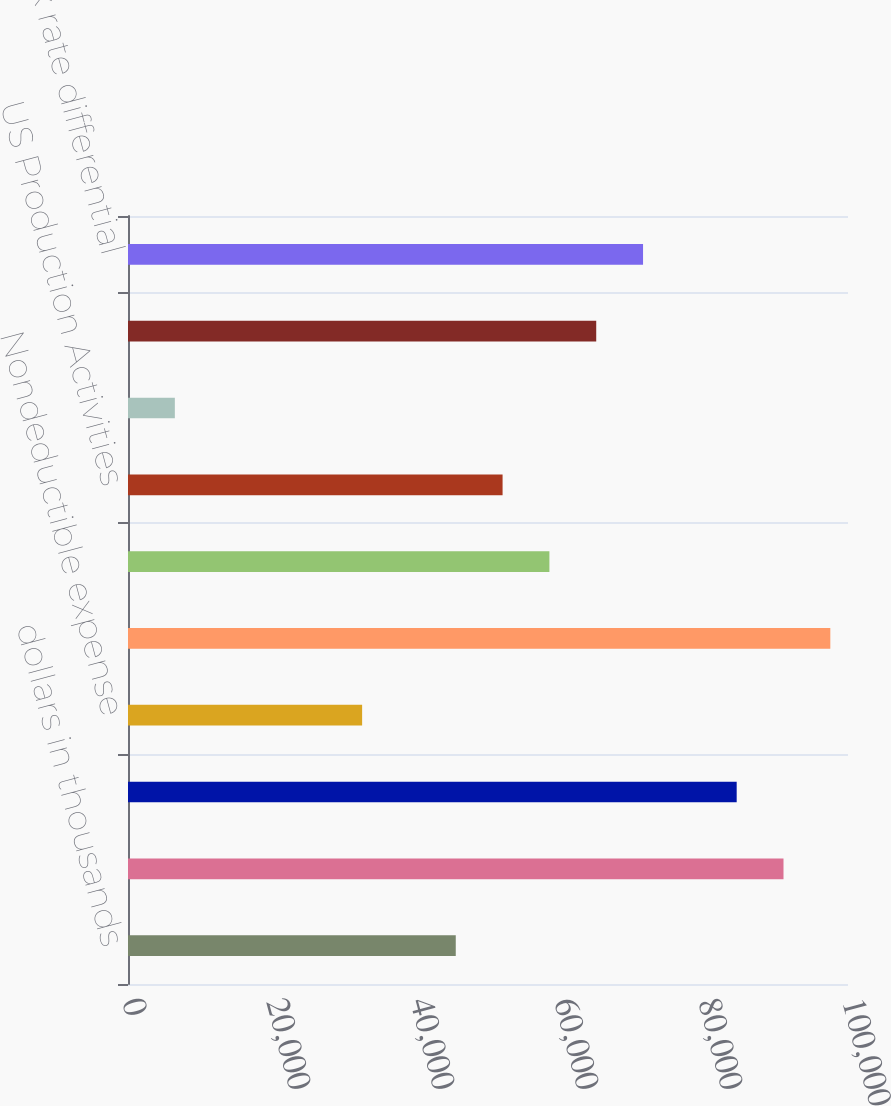Convert chart. <chart><loc_0><loc_0><loc_500><loc_500><bar_chart><fcel>dollars in thousands<fcel>Income tax provision (benefit)<fcel>State and local income taxes<fcel>Nondeductible expense<fcel>Goodwill impairment<fcel>ESOP dividend deduction<fcel>US Production Activities<fcel>Recapture US Production<fcel>Fair market value over tax<fcel>Foreign tax rate differential<nl><fcel>45522.6<fcel>91042.3<fcel>84539.5<fcel>32516.9<fcel>97545.1<fcel>58528.2<fcel>52025.4<fcel>6505.66<fcel>65031<fcel>71533.9<nl></chart> 